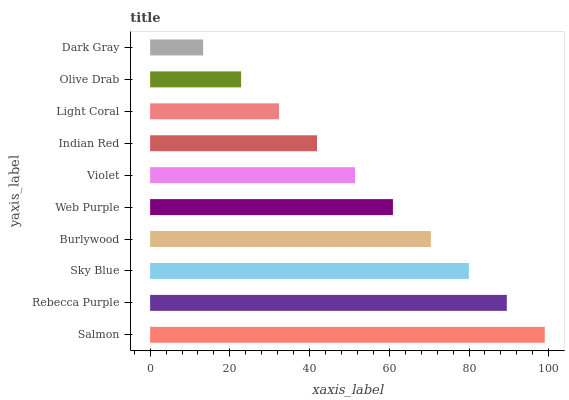Is Dark Gray the minimum?
Answer yes or no. Yes. Is Salmon the maximum?
Answer yes or no. Yes. Is Rebecca Purple the minimum?
Answer yes or no. No. Is Rebecca Purple the maximum?
Answer yes or no. No. Is Salmon greater than Rebecca Purple?
Answer yes or no. Yes. Is Rebecca Purple less than Salmon?
Answer yes or no. Yes. Is Rebecca Purple greater than Salmon?
Answer yes or no. No. Is Salmon less than Rebecca Purple?
Answer yes or no. No. Is Web Purple the high median?
Answer yes or no. Yes. Is Violet the low median?
Answer yes or no. Yes. Is Violet the high median?
Answer yes or no. No. Is Olive Drab the low median?
Answer yes or no. No. 